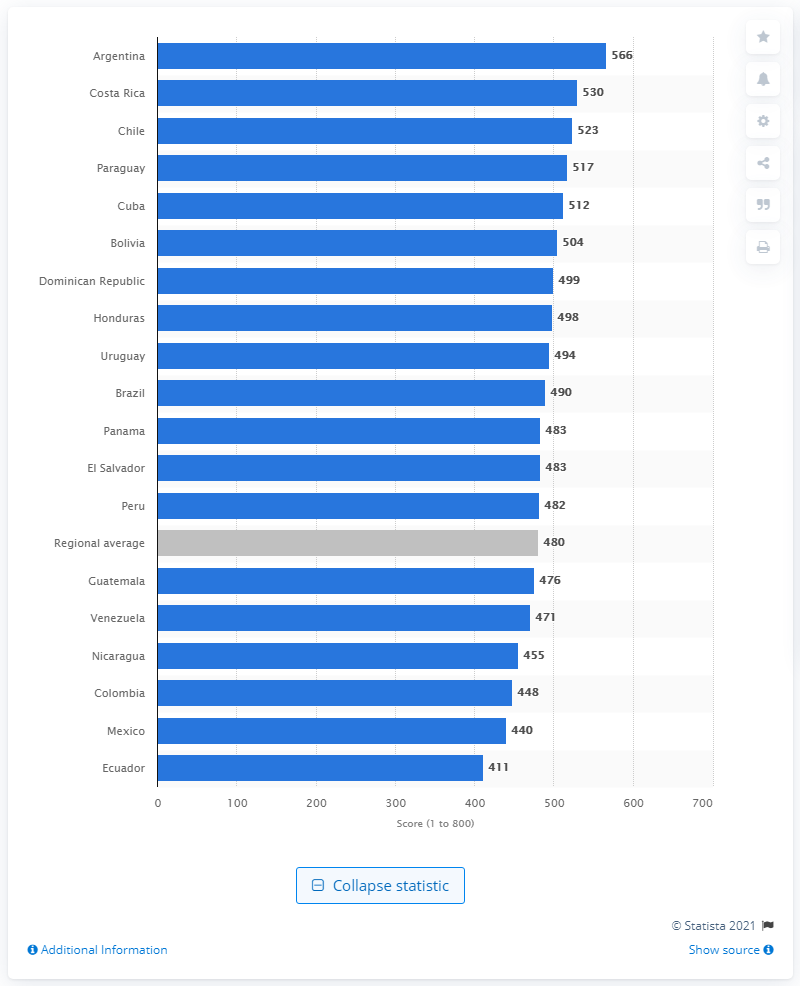Mention a couple of crucial points in this snapshot. Argentina scored 566 points in the English Proficiency Index 2020. 